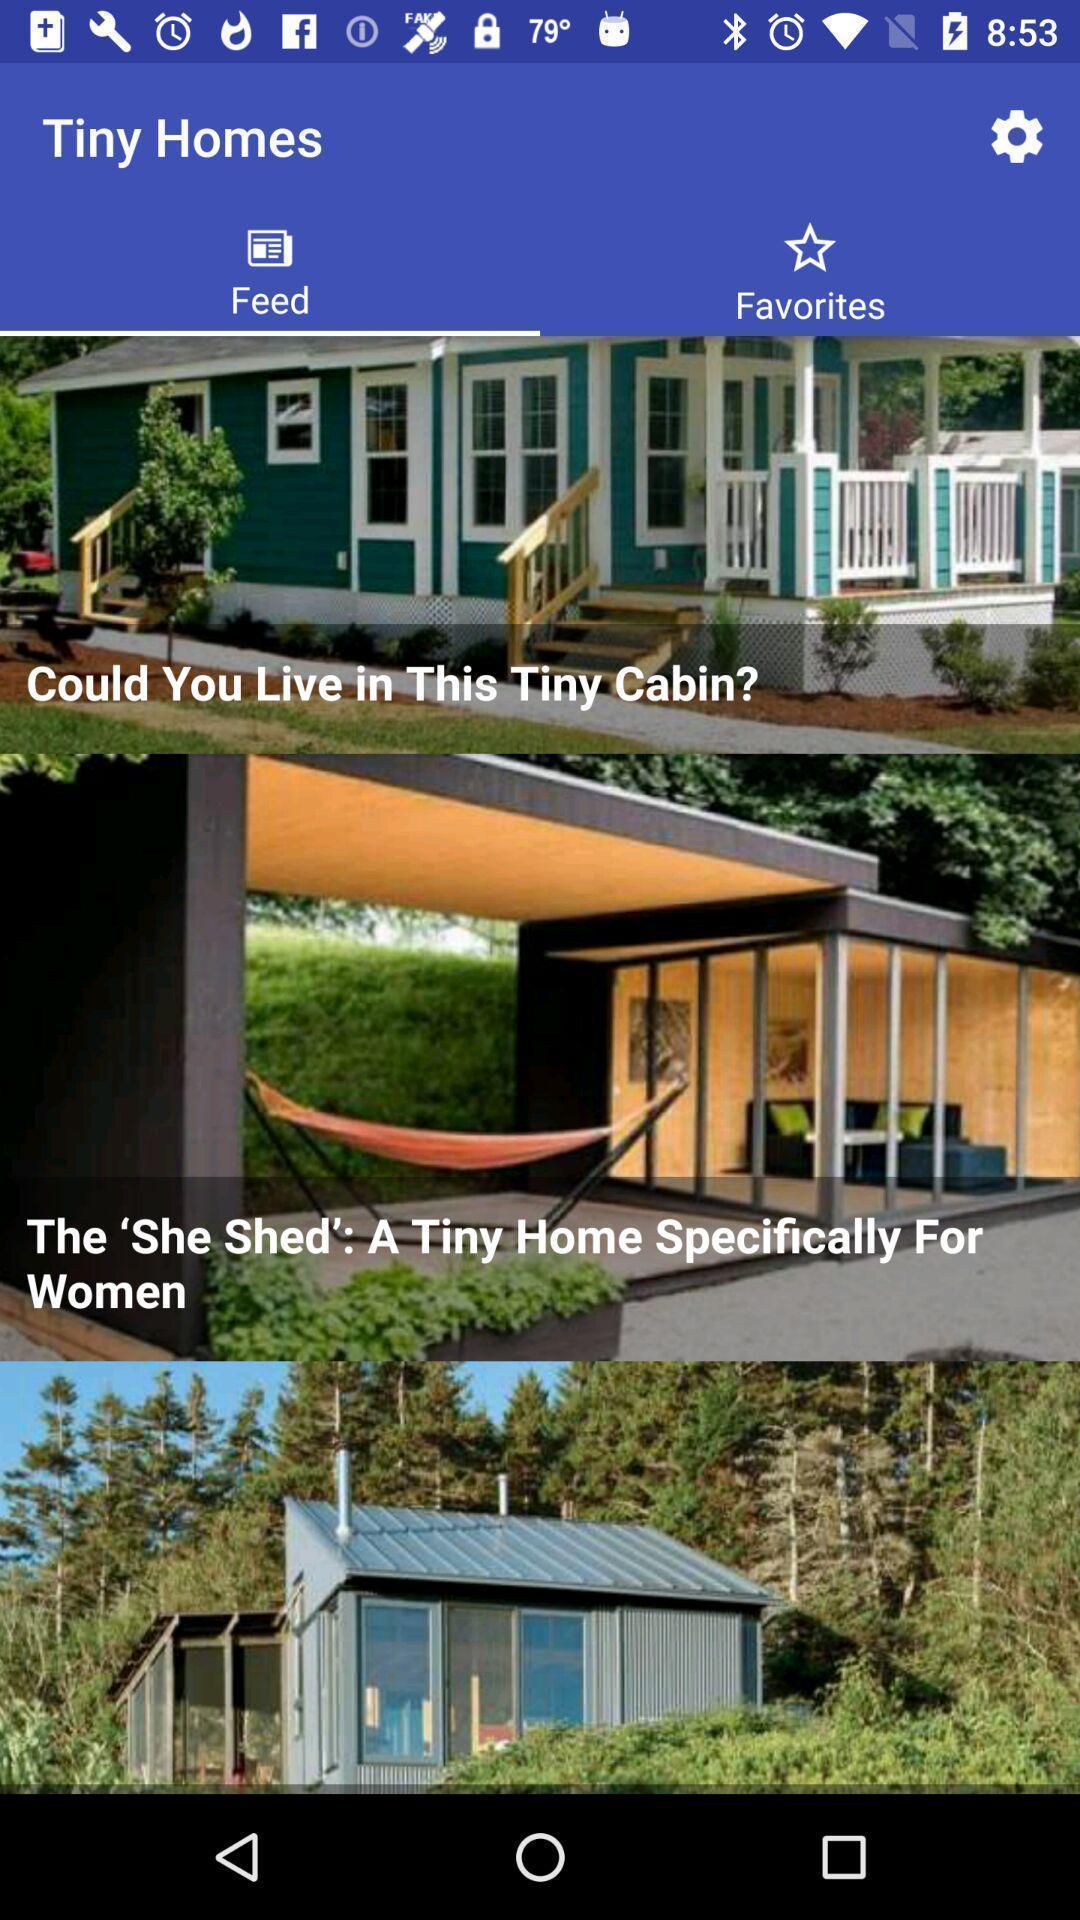Describe the content in this image. Page displaying different feeds available. 